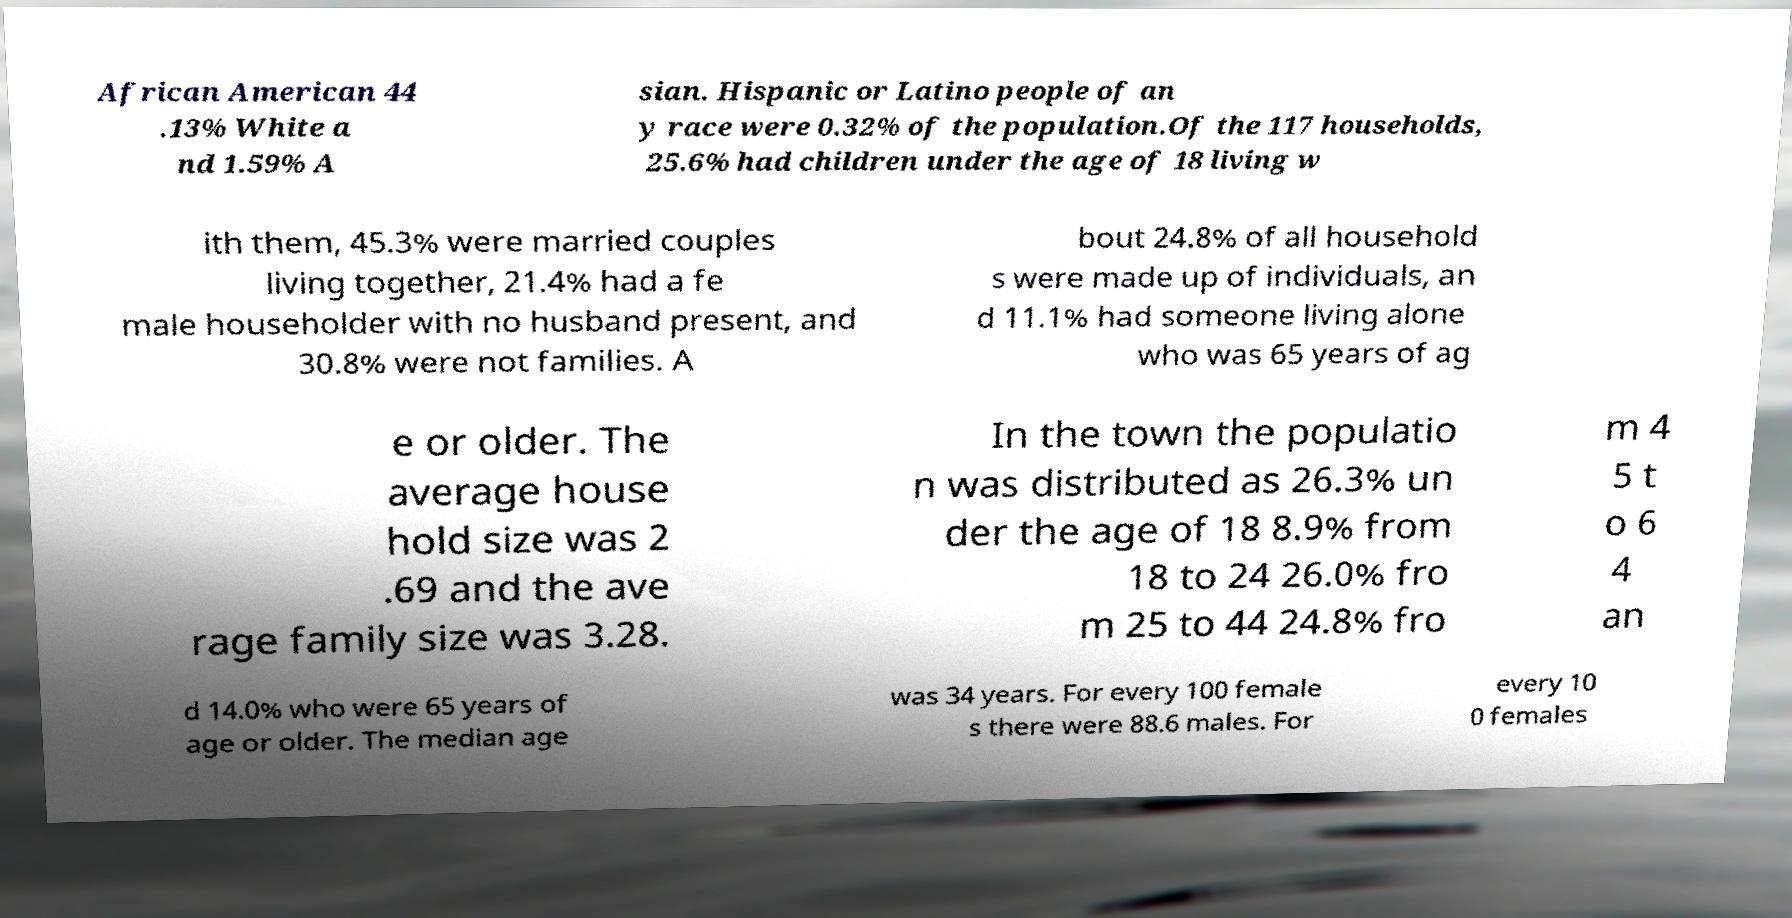Please identify and transcribe the text found in this image. African American 44 .13% White a nd 1.59% A sian. Hispanic or Latino people of an y race were 0.32% of the population.Of the 117 households, 25.6% had children under the age of 18 living w ith them, 45.3% were married couples living together, 21.4% had a fe male householder with no husband present, and 30.8% were not families. A bout 24.8% of all household s were made up of individuals, an d 11.1% had someone living alone who was 65 years of ag e or older. The average house hold size was 2 .69 and the ave rage family size was 3.28. In the town the populatio n was distributed as 26.3% un der the age of 18 8.9% from 18 to 24 26.0% fro m 25 to 44 24.8% fro m 4 5 t o 6 4 an d 14.0% who were 65 years of age or older. The median age was 34 years. For every 100 female s there were 88.6 males. For every 10 0 females 